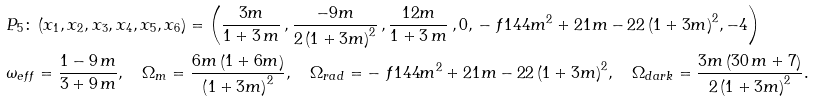<formula> <loc_0><loc_0><loc_500><loc_500>& P _ { 5 } \colon \left ( x _ { 1 } , x _ { 2 } , x _ { 3 } , x _ { 4 } , x _ { 5 } , x _ { 6 } \right ) = \left ( { \frac { 3 m } { 1 + 3 \, m } } \, , { \frac { - 9 m } { 2 \left ( 1 + 3 m \right ) ^ { 2 } } } \, , { \frac { 1 2 m } { 1 + 3 \, m } } \, , 0 , \, - \ f { 1 4 4 m ^ { 2 } + 2 1 m - 2 } { 2 \left ( 1 + 3 m \right ) ^ { 2 } } , - 4 \right ) \\ & \omega _ { e f f } = { \frac { 1 - 9 \, m } { 3 + 9 \, m } } , \quad \Omega _ { m } = \frac { 6 m \left ( 1 + 6 m \right ) } { \left ( 1 + 3 m \right ) ^ { 2 } } , \quad \Omega _ { r a d } = - \ f { 1 4 4 m ^ { 2 } + 2 1 m - 2 } { 2 \left ( 1 + 3 m \right ) ^ { 2 } } , \quad \Omega _ { d a r k } = \frac { 3 m \left ( 3 0 \, m + 7 \right ) } { 2 \left ( 1 + 3 m \right ) ^ { 2 } } .</formula> 